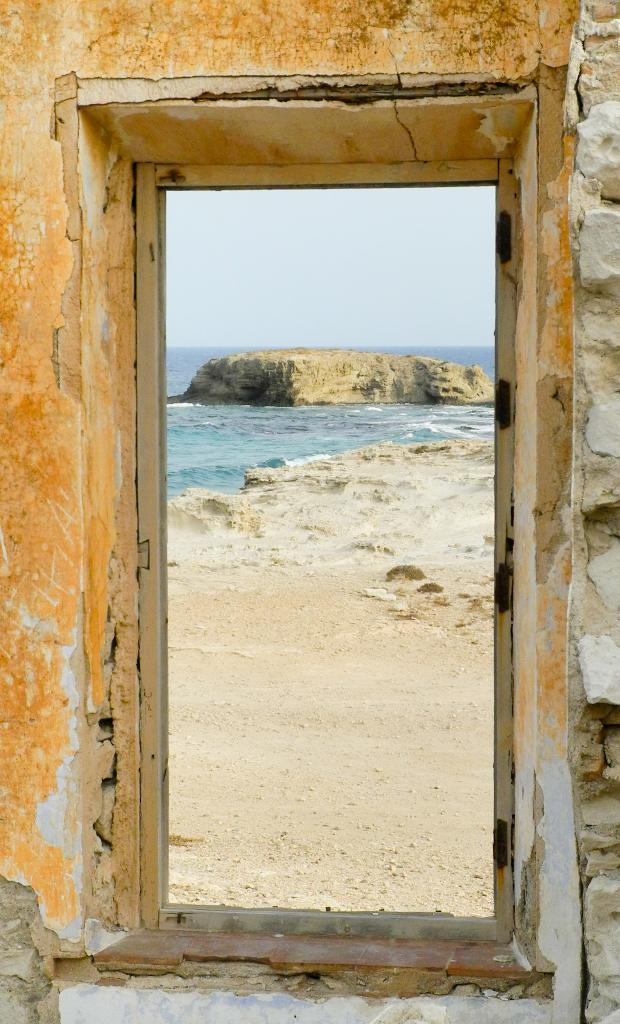What is the main object in the image? There is a door in the image. Where is the door located? The door is attached to a wall. What can be seen in the background of the image? Water, sand, and the sky are visible in the background of the image. What type of marble is being used to decorate the door in the image? There is no marble present in the image; the door is attached to a wall with no visible decoration. Can you describe the haircut of the person standing next to the door in the image? There is no person present in the image, so it is not possible to describe their haircut. 